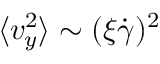Convert formula to latex. <formula><loc_0><loc_0><loc_500><loc_500>\langle v _ { y } ^ { 2 } \rangle \sim ( \xi \dot { \gamma } ) ^ { 2 }</formula> 